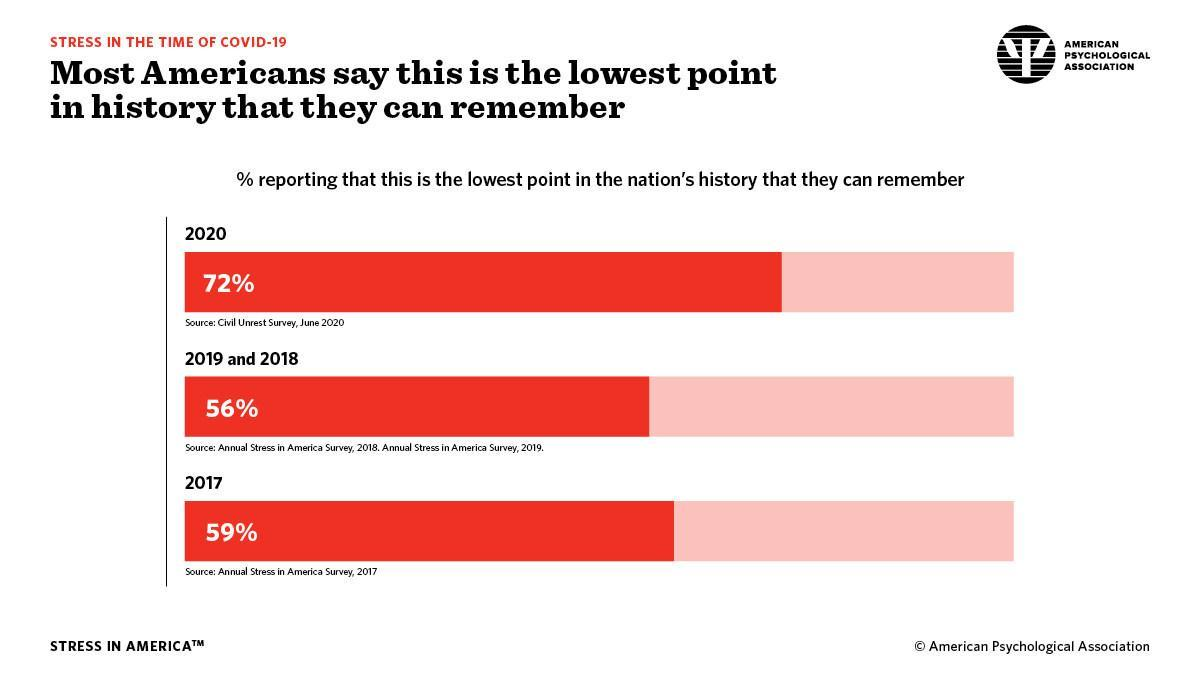What percentage of Americans disagree that 2019 and 2018 are the lowest point in history?
Answer the question with a short phrase. 44% What percentage of Americans disagree that 2020 is the lowest point in history? 28% What percentage of Americans disagree that 2017 is the lowest point in history? 41% 